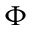Convert formula to latex. <formula><loc_0><loc_0><loc_500><loc_500>\Phi</formula> 